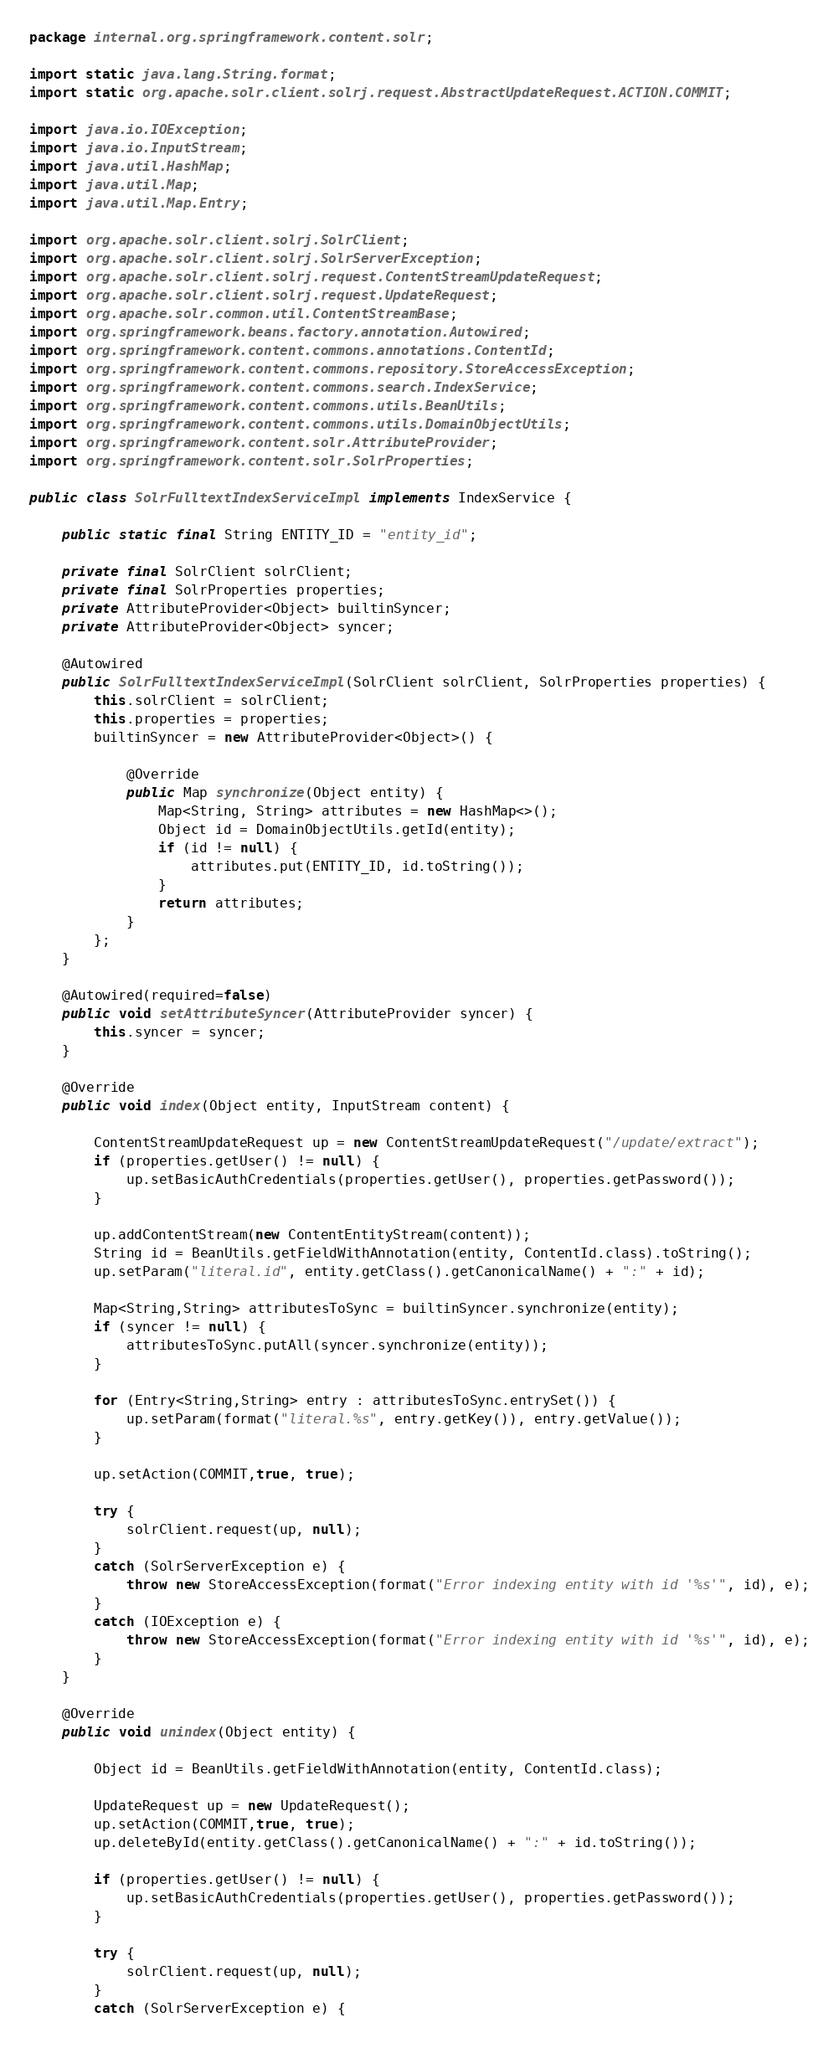Convert code to text. <code><loc_0><loc_0><loc_500><loc_500><_Java_>package internal.org.springframework.content.solr;

import static java.lang.String.format;
import static org.apache.solr.client.solrj.request.AbstractUpdateRequest.ACTION.COMMIT;

import java.io.IOException;
import java.io.InputStream;
import java.util.HashMap;
import java.util.Map;
import java.util.Map.Entry;

import org.apache.solr.client.solrj.SolrClient;
import org.apache.solr.client.solrj.SolrServerException;
import org.apache.solr.client.solrj.request.ContentStreamUpdateRequest;
import org.apache.solr.client.solrj.request.UpdateRequest;
import org.apache.solr.common.util.ContentStreamBase;
import org.springframework.beans.factory.annotation.Autowired;
import org.springframework.content.commons.annotations.ContentId;
import org.springframework.content.commons.repository.StoreAccessException;
import org.springframework.content.commons.search.IndexService;
import org.springframework.content.commons.utils.BeanUtils;
import org.springframework.content.commons.utils.DomainObjectUtils;
import org.springframework.content.solr.AttributeProvider;
import org.springframework.content.solr.SolrProperties;

public class SolrFulltextIndexServiceImpl implements IndexService {

    public static final String ENTITY_ID = "entity_id";

    private final SolrClient solrClient;
    private final SolrProperties properties;
    private AttributeProvider<Object> builtinSyncer;
    private AttributeProvider<Object> syncer;

    @Autowired
    public SolrFulltextIndexServiceImpl(SolrClient solrClient, SolrProperties properties) {
        this.solrClient = solrClient;
        this.properties = properties;
        builtinSyncer = new AttributeProvider<Object>() {

            @Override
            public Map synchronize(Object entity) {
                Map<String, String> attributes = new HashMap<>();
                Object id = DomainObjectUtils.getId(entity);
                if (id != null) {
                    attributes.put(ENTITY_ID, id.toString());
                }
                return attributes;
            }
        };
    }

    @Autowired(required=false)
    public void setAttributeSyncer(AttributeProvider syncer) {
        this.syncer = syncer;
    }

    @Override
    public void index(Object entity, InputStream content) {

        ContentStreamUpdateRequest up = new ContentStreamUpdateRequest("/update/extract");
        if (properties.getUser() != null) {
            up.setBasicAuthCredentials(properties.getUser(), properties.getPassword());
        }

        up.addContentStream(new ContentEntityStream(content));
        String id = BeanUtils.getFieldWithAnnotation(entity, ContentId.class).toString();
        up.setParam("literal.id", entity.getClass().getCanonicalName() + ":" + id);

        Map<String,String> attributesToSync = builtinSyncer.synchronize(entity);
        if (syncer != null) {
            attributesToSync.putAll(syncer.synchronize(entity));
        }

        for (Entry<String,String> entry : attributesToSync.entrySet()) {
            up.setParam(format("literal.%s", entry.getKey()), entry.getValue());
        }

        up.setAction(COMMIT,true, true);

        try {
            solrClient.request(up, null);
        }
        catch (SolrServerException e) {
            throw new StoreAccessException(format("Error indexing entity with id '%s'", id), e);
        }
        catch (IOException e) {
            throw new StoreAccessException(format("Error indexing entity with id '%s'", id), e);
        }
    }

    @Override
    public void unindex(Object entity) {

        Object id = BeanUtils.getFieldWithAnnotation(entity, ContentId.class);

        UpdateRequest up = new UpdateRequest();
        up.setAction(COMMIT,true, true);
        up.deleteById(entity.getClass().getCanonicalName() + ":" + id.toString());

        if (properties.getUser() != null) {
            up.setBasicAuthCredentials(properties.getUser(), properties.getPassword());
        }

        try {
            solrClient.request(up, null);
        }
        catch (SolrServerException e) {</code> 